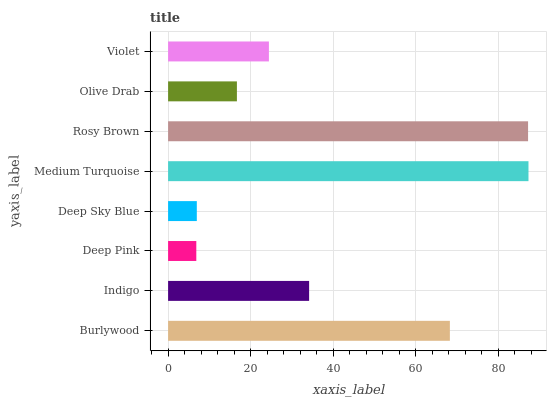Is Deep Pink the minimum?
Answer yes or no. Yes. Is Medium Turquoise the maximum?
Answer yes or no. Yes. Is Indigo the minimum?
Answer yes or no. No. Is Indigo the maximum?
Answer yes or no. No. Is Burlywood greater than Indigo?
Answer yes or no. Yes. Is Indigo less than Burlywood?
Answer yes or no. Yes. Is Indigo greater than Burlywood?
Answer yes or no. No. Is Burlywood less than Indigo?
Answer yes or no. No. Is Indigo the high median?
Answer yes or no. Yes. Is Violet the low median?
Answer yes or no. Yes. Is Violet the high median?
Answer yes or no. No. Is Olive Drab the low median?
Answer yes or no. No. 